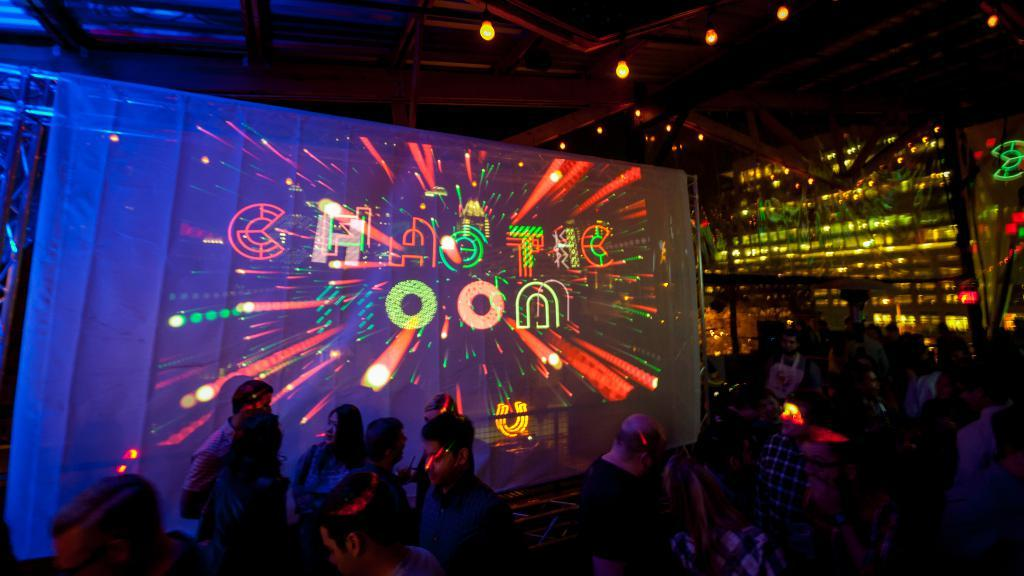<image>
Share a concise interpretation of the image provided. People are at a night club partying with a giant projected sign that says Chaotic Moon. 